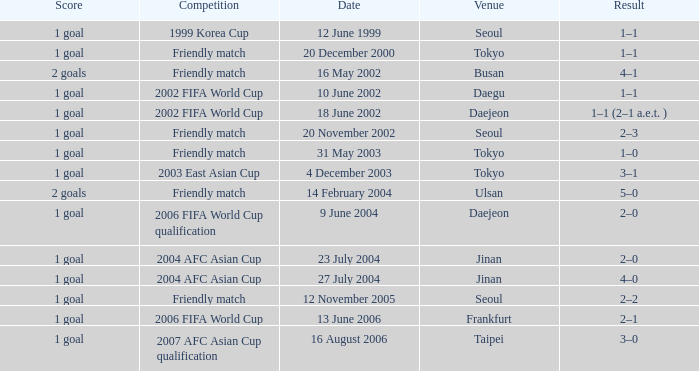What is the venue for the event on 12 November 2005? Seoul. 